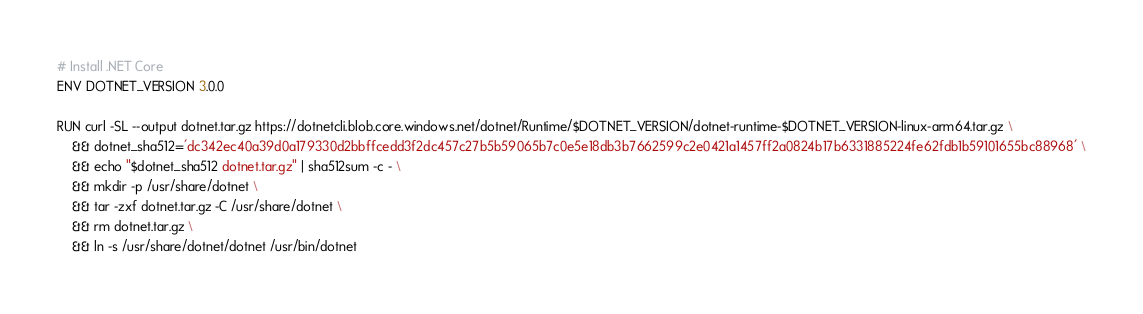<code> <loc_0><loc_0><loc_500><loc_500><_Dockerfile_># Install .NET Core
ENV DOTNET_VERSION 3.0.0

RUN curl -SL --output dotnet.tar.gz https://dotnetcli.blob.core.windows.net/dotnet/Runtime/$DOTNET_VERSION/dotnet-runtime-$DOTNET_VERSION-linux-arm64.tar.gz \
    && dotnet_sha512='dc342ec40a39d0a179330d2bbffcedd3f2dc457c27b5b59065b7c0e5e18db3b7662599c2e0421a1457ff2a0824b17b6331885224fe62fdb1b59101655bc88968' \
    && echo "$dotnet_sha512 dotnet.tar.gz" | sha512sum -c - \
    && mkdir -p /usr/share/dotnet \
    && tar -zxf dotnet.tar.gz -C /usr/share/dotnet \
    && rm dotnet.tar.gz \
    && ln -s /usr/share/dotnet/dotnet /usr/bin/dotnet
</code> 